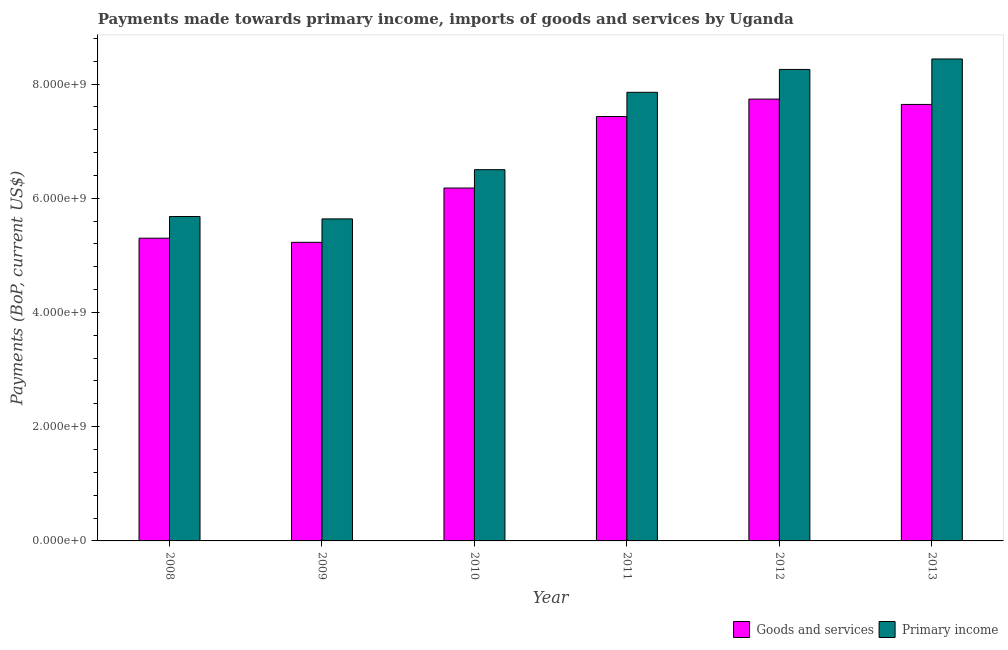How many groups of bars are there?
Provide a short and direct response. 6. Are the number of bars per tick equal to the number of legend labels?
Provide a succinct answer. Yes. Are the number of bars on each tick of the X-axis equal?
Provide a succinct answer. Yes. How many bars are there on the 5th tick from the left?
Give a very brief answer. 2. What is the payments made towards primary income in 2013?
Ensure brevity in your answer.  8.44e+09. Across all years, what is the maximum payments made towards primary income?
Your response must be concise. 8.44e+09. Across all years, what is the minimum payments made towards primary income?
Your answer should be compact. 5.64e+09. In which year was the payments made towards primary income minimum?
Make the answer very short. 2009. What is the total payments made towards primary income in the graph?
Offer a terse response. 4.24e+1. What is the difference between the payments made towards primary income in 2008 and that in 2012?
Keep it short and to the point. -2.57e+09. What is the difference between the payments made towards goods and services in 2009 and the payments made towards primary income in 2008?
Your answer should be compact. -7.20e+07. What is the average payments made towards primary income per year?
Ensure brevity in your answer.  7.06e+09. What is the ratio of the payments made towards goods and services in 2011 to that in 2013?
Provide a succinct answer. 0.97. Is the difference between the payments made towards goods and services in 2008 and 2011 greater than the difference between the payments made towards primary income in 2008 and 2011?
Provide a short and direct response. No. What is the difference between the highest and the second highest payments made towards primary income?
Ensure brevity in your answer.  1.83e+08. What is the difference between the highest and the lowest payments made towards primary income?
Your answer should be very brief. 2.80e+09. In how many years, is the payments made towards goods and services greater than the average payments made towards goods and services taken over all years?
Your response must be concise. 3. Is the sum of the payments made towards primary income in 2008 and 2012 greater than the maximum payments made towards goods and services across all years?
Your response must be concise. Yes. What does the 2nd bar from the left in 2013 represents?
Offer a terse response. Primary income. What does the 2nd bar from the right in 2011 represents?
Provide a short and direct response. Goods and services. Are all the bars in the graph horizontal?
Offer a very short reply. No. How many years are there in the graph?
Your answer should be compact. 6. What is the difference between two consecutive major ticks on the Y-axis?
Keep it short and to the point. 2.00e+09. Does the graph contain grids?
Offer a very short reply. No. Where does the legend appear in the graph?
Keep it short and to the point. Bottom right. How many legend labels are there?
Provide a succinct answer. 2. What is the title of the graph?
Make the answer very short. Payments made towards primary income, imports of goods and services by Uganda. Does "Private creditors" appear as one of the legend labels in the graph?
Offer a very short reply. No. What is the label or title of the Y-axis?
Ensure brevity in your answer.  Payments (BoP, current US$). What is the Payments (BoP, current US$) in Goods and services in 2008?
Provide a short and direct response. 5.30e+09. What is the Payments (BoP, current US$) of Primary income in 2008?
Your answer should be compact. 5.68e+09. What is the Payments (BoP, current US$) of Goods and services in 2009?
Offer a terse response. 5.23e+09. What is the Payments (BoP, current US$) of Primary income in 2009?
Give a very brief answer. 5.64e+09. What is the Payments (BoP, current US$) in Goods and services in 2010?
Offer a terse response. 6.18e+09. What is the Payments (BoP, current US$) of Primary income in 2010?
Provide a short and direct response. 6.50e+09. What is the Payments (BoP, current US$) of Goods and services in 2011?
Offer a very short reply. 7.43e+09. What is the Payments (BoP, current US$) of Primary income in 2011?
Offer a terse response. 7.85e+09. What is the Payments (BoP, current US$) of Goods and services in 2012?
Make the answer very short. 7.74e+09. What is the Payments (BoP, current US$) in Primary income in 2012?
Offer a terse response. 8.25e+09. What is the Payments (BoP, current US$) of Goods and services in 2013?
Give a very brief answer. 7.64e+09. What is the Payments (BoP, current US$) of Primary income in 2013?
Give a very brief answer. 8.44e+09. Across all years, what is the maximum Payments (BoP, current US$) of Goods and services?
Your answer should be compact. 7.74e+09. Across all years, what is the maximum Payments (BoP, current US$) in Primary income?
Give a very brief answer. 8.44e+09. Across all years, what is the minimum Payments (BoP, current US$) of Goods and services?
Provide a succinct answer. 5.23e+09. Across all years, what is the minimum Payments (BoP, current US$) of Primary income?
Your answer should be compact. 5.64e+09. What is the total Payments (BoP, current US$) in Goods and services in the graph?
Your answer should be very brief. 3.95e+1. What is the total Payments (BoP, current US$) of Primary income in the graph?
Keep it short and to the point. 4.24e+1. What is the difference between the Payments (BoP, current US$) in Goods and services in 2008 and that in 2009?
Make the answer very short. 7.20e+07. What is the difference between the Payments (BoP, current US$) in Primary income in 2008 and that in 2009?
Provide a succinct answer. 4.20e+07. What is the difference between the Payments (BoP, current US$) of Goods and services in 2008 and that in 2010?
Your answer should be compact. -8.78e+08. What is the difference between the Payments (BoP, current US$) of Primary income in 2008 and that in 2010?
Your response must be concise. -8.20e+08. What is the difference between the Payments (BoP, current US$) in Goods and services in 2008 and that in 2011?
Offer a terse response. -2.13e+09. What is the difference between the Payments (BoP, current US$) in Primary income in 2008 and that in 2011?
Your answer should be compact. -2.17e+09. What is the difference between the Payments (BoP, current US$) in Goods and services in 2008 and that in 2012?
Provide a succinct answer. -2.44e+09. What is the difference between the Payments (BoP, current US$) in Primary income in 2008 and that in 2012?
Offer a terse response. -2.57e+09. What is the difference between the Payments (BoP, current US$) of Goods and services in 2008 and that in 2013?
Keep it short and to the point. -2.34e+09. What is the difference between the Payments (BoP, current US$) of Primary income in 2008 and that in 2013?
Your answer should be very brief. -2.76e+09. What is the difference between the Payments (BoP, current US$) in Goods and services in 2009 and that in 2010?
Your answer should be compact. -9.50e+08. What is the difference between the Payments (BoP, current US$) of Primary income in 2009 and that in 2010?
Ensure brevity in your answer.  -8.62e+08. What is the difference between the Payments (BoP, current US$) in Goods and services in 2009 and that in 2011?
Keep it short and to the point. -2.20e+09. What is the difference between the Payments (BoP, current US$) of Primary income in 2009 and that in 2011?
Your answer should be compact. -2.22e+09. What is the difference between the Payments (BoP, current US$) in Goods and services in 2009 and that in 2012?
Provide a succinct answer. -2.51e+09. What is the difference between the Payments (BoP, current US$) of Primary income in 2009 and that in 2012?
Provide a short and direct response. -2.62e+09. What is the difference between the Payments (BoP, current US$) of Goods and services in 2009 and that in 2013?
Ensure brevity in your answer.  -2.41e+09. What is the difference between the Payments (BoP, current US$) of Primary income in 2009 and that in 2013?
Keep it short and to the point. -2.80e+09. What is the difference between the Payments (BoP, current US$) in Goods and services in 2010 and that in 2011?
Give a very brief answer. -1.25e+09. What is the difference between the Payments (BoP, current US$) of Primary income in 2010 and that in 2011?
Provide a succinct answer. -1.35e+09. What is the difference between the Payments (BoP, current US$) in Goods and services in 2010 and that in 2012?
Give a very brief answer. -1.56e+09. What is the difference between the Payments (BoP, current US$) of Primary income in 2010 and that in 2012?
Ensure brevity in your answer.  -1.75e+09. What is the difference between the Payments (BoP, current US$) of Goods and services in 2010 and that in 2013?
Offer a terse response. -1.46e+09. What is the difference between the Payments (BoP, current US$) in Primary income in 2010 and that in 2013?
Your response must be concise. -1.94e+09. What is the difference between the Payments (BoP, current US$) in Goods and services in 2011 and that in 2012?
Offer a very short reply. -3.05e+08. What is the difference between the Payments (BoP, current US$) of Primary income in 2011 and that in 2012?
Offer a terse response. -4.00e+08. What is the difference between the Payments (BoP, current US$) of Goods and services in 2011 and that in 2013?
Offer a very short reply. -2.12e+08. What is the difference between the Payments (BoP, current US$) of Primary income in 2011 and that in 2013?
Keep it short and to the point. -5.84e+08. What is the difference between the Payments (BoP, current US$) of Goods and services in 2012 and that in 2013?
Keep it short and to the point. 9.31e+07. What is the difference between the Payments (BoP, current US$) of Primary income in 2012 and that in 2013?
Keep it short and to the point. -1.83e+08. What is the difference between the Payments (BoP, current US$) of Goods and services in 2008 and the Payments (BoP, current US$) of Primary income in 2009?
Your response must be concise. -3.38e+08. What is the difference between the Payments (BoP, current US$) in Goods and services in 2008 and the Payments (BoP, current US$) in Primary income in 2010?
Offer a very short reply. -1.20e+09. What is the difference between the Payments (BoP, current US$) of Goods and services in 2008 and the Payments (BoP, current US$) of Primary income in 2011?
Offer a terse response. -2.55e+09. What is the difference between the Payments (BoP, current US$) of Goods and services in 2008 and the Payments (BoP, current US$) of Primary income in 2012?
Give a very brief answer. -2.95e+09. What is the difference between the Payments (BoP, current US$) in Goods and services in 2008 and the Payments (BoP, current US$) in Primary income in 2013?
Offer a terse response. -3.14e+09. What is the difference between the Payments (BoP, current US$) in Goods and services in 2009 and the Payments (BoP, current US$) in Primary income in 2010?
Provide a short and direct response. -1.27e+09. What is the difference between the Payments (BoP, current US$) in Goods and services in 2009 and the Payments (BoP, current US$) in Primary income in 2011?
Your response must be concise. -2.63e+09. What is the difference between the Payments (BoP, current US$) in Goods and services in 2009 and the Payments (BoP, current US$) in Primary income in 2012?
Ensure brevity in your answer.  -3.03e+09. What is the difference between the Payments (BoP, current US$) of Goods and services in 2009 and the Payments (BoP, current US$) of Primary income in 2013?
Offer a very short reply. -3.21e+09. What is the difference between the Payments (BoP, current US$) of Goods and services in 2010 and the Payments (BoP, current US$) of Primary income in 2011?
Your response must be concise. -1.68e+09. What is the difference between the Payments (BoP, current US$) in Goods and services in 2010 and the Payments (BoP, current US$) in Primary income in 2012?
Your answer should be compact. -2.08e+09. What is the difference between the Payments (BoP, current US$) in Goods and services in 2010 and the Payments (BoP, current US$) in Primary income in 2013?
Provide a succinct answer. -2.26e+09. What is the difference between the Payments (BoP, current US$) of Goods and services in 2011 and the Payments (BoP, current US$) of Primary income in 2012?
Your answer should be very brief. -8.24e+08. What is the difference between the Payments (BoP, current US$) in Goods and services in 2011 and the Payments (BoP, current US$) in Primary income in 2013?
Give a very brief answer. -1.01e+09. What is the difference between the Payments (BoP, current US$) of Goods and services in 2012 and the Payments (BoP, current US$) of Primary income in 2013?
Your response must be concise. -7.03e+08. What is the average Payments (BoP, current US$) of Goods and services per year?
Your answer should be compact. 6.59e+09. What is the average Payments (BoP, current US$) of Primary income per year?
Your response must be concise. 7.06e+09. In the year 2008, what is the difference between the Payments (BoP, current US$) of Goods and services and Payments (BoP, current US$) of Primary income?
Your answer should be compact. -3.80e+08. In the year 2009, what is the difference between the Payments (BoP, current US$) of Goods and services and Payments (BoP, current US$) of Primary income?
Your answer should be very brief. -4.10e+08. In the year 2010, what is the difference between the Payments (BoP, current US$) of Goods and services and Payments (BoP, current US$) of Primary income?
Ensure brevity in your answer.  -3.21e+08. In the year 2011, what is the difference between the Payments (BoP, current US$) in Goods and services and Payments (BoP, current US$) in Primary income?
Ensure brevity in your answer.  -4.24e+08. In the year 2012, what is the difference between the Payments (BoP, current US$) of Goods and services and Payments (BoP, current US$) of Primary income?
Provide a short and direct response. -5.19e+08. In the year 2013, what is the difference between the Payments (BoP, current US$) of Goods and services and Payments (BoP, current US$) of Primary income?
Provide a short and direct response. -7.96e+08. What is the ratio of the Payments (BoP, current US$) of Goods and services in 2008 to that in 2009?
Give a very brief answer. 1.01. What is the ratio of the Payments (BoP, current US$) of Primary income in 2008 to that in 2009?
Make the answer very short. 1.01. What is the ratio of the Payments (BoP, current US$) in Goods and services in 2008 to that in 2010?
Make the answer very short. 0.86. What is the ratio of the Payments (BoP, current US$) of Primary income in 2008 to that in 2010?
Provide a short and direct response. 0.87. What is the ratio of the Payments (BoP, current US$) in Goods and services in 2008 to that in 2011?
Make the answer very short. 0.71. What is the ratio of the Payments (BoP, current US$) in Primary income in 2008 to that in 2011?
Your answer should be compact. 0.72. What is the ratio of the Payments (BoP, current US$) of Goods and services in 2008 to that in 2012?
Your answer should be very brief. 0.69. What is the ratio of the Payments (BoP, current US$) in Primary income in 2008 to that in 2012?
Your answer should be very brief. 0.69. What is the ratio of the Payments (BoP, current US$) in Goods and services in 2008 to that in 2013?
Keep it short and to the point. 0.69. What is the ratio of the Payments (BoP, current US$) in Primary income in 2008 to that in 2013?
Ensure brevity in your answer.  0.67. What is the ratio of the Payments (BoP, current US$) in Goods and services in 2009 to that in 2010?
Make the answer very short. 0.85. What is the ratio of the Payments (BoP, current US$) in Primary income in 2009 to that in 2010?
Give a very brief answer. 0.87. What is the ratio of the Payments (BoP, current US$) of Goods and services in 2009 to that in 2011?
Give a very brief answer. 0.7. What is the ratio of the Payments (BoP, current US$) in Primary income in 2009 to that in 2011?
Make the answer very short. 0.72. What is the ratio of the Payments (BoP, current US$) in Goods and services in 2009 to that in 2012?
Your answer should be compact. 0.68. What is the ratio of the Payments (BoP, current US$) in Primary income in 2009 to that in 2012?
Your answer should be very brief. 0.68. What is the ratio of the Payments (BoP, current US$) of Goods and services in 2009 to that in 2013?
Give a very brief answer. 0.68. What is the ratio of the Payments (BoP, current US$) in Primary income in 2009 to that in 2013?
Provide a short and direct response. 0.67. What is the ratio of the Payments (BoP, current US$) in Goods and services in 2010 to that in 2011?
Your answer should be compact. 0.83. What is the ratio of the Payments (BoP, current US$) of Primary income in 2010 to that in 2011?
Provide a succinct answer. 0.83. What is the ratio of the Payments (BoP, current US$) in Goods and services in 2010 to that in 2012?
Make the answer very short. 0.8. What is the ratio of the Payments (BoP, current US$) in Primary income in 2010 to that in 2012?
Keep it short and to the point. 0.79. What is the ratio of the Payments (BoP, current US$) in Goods and services in 2010 to that in 2013?
Ensure brevity in your answer.  0.81. What is the ratio of the Payments (BoP, current US$) of Primary income in 2010 to that in 2013?
Your answer should be compact. 0.77. What is the ratio of the Payments (BoP, current US$) in Goods and services in 2011 to that in 2012?
Keep it short and to the point. 0.96. What is the ratio of the Payments (BoP, current US$) in Primary income in 2011 to that in 2012?
Offer a terse response. 0.95. What is the ratio of the Payments (BoP, current US$) in Goods and services in 2011 to that in 2013?
Offer a very short reply. 0.97. What is the ratio of the Payments (BoP, current US$) in Primary income in 2011 to that in 2013?
Provide a succinct answer. 0.93. What is the ratio of the Payments (BoP, current US$) in Goods and services in 2012 to that in 2013?
Provide a short and direct response. 1.01. What is the ratio of the Payments (BoP, current US$) in Primary income in 2012 to that in 2013?
Make the answer very short. 0.98. What is the difference between the highest and the second highest Payments (BoP, current US$) of Goods and services?
Make the answer very short. 9.31e+07. What is the difference between the highest and the second highest Payments (BoP, current US$) in Primary income?
Offer a very short reply. 1.83e+08. What is the difference between the highest and the lowest Payments (BoP, current US$) of Goods and services?
Provide a succinct answer. 2.51e+09. What is the difference between the highest and the lowest Payments (BoP, current US$) in Primary income?
Keep it short and to the point. 2.80e+09. 